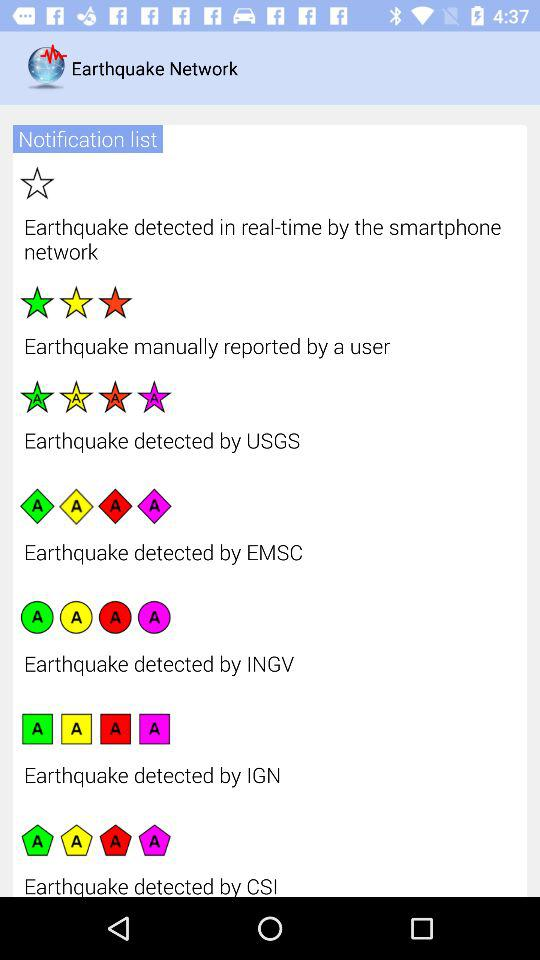How many stars has the earthquake detected by USGS?
When the provided information is insufficient, respond with <no answer>. <no answer> 